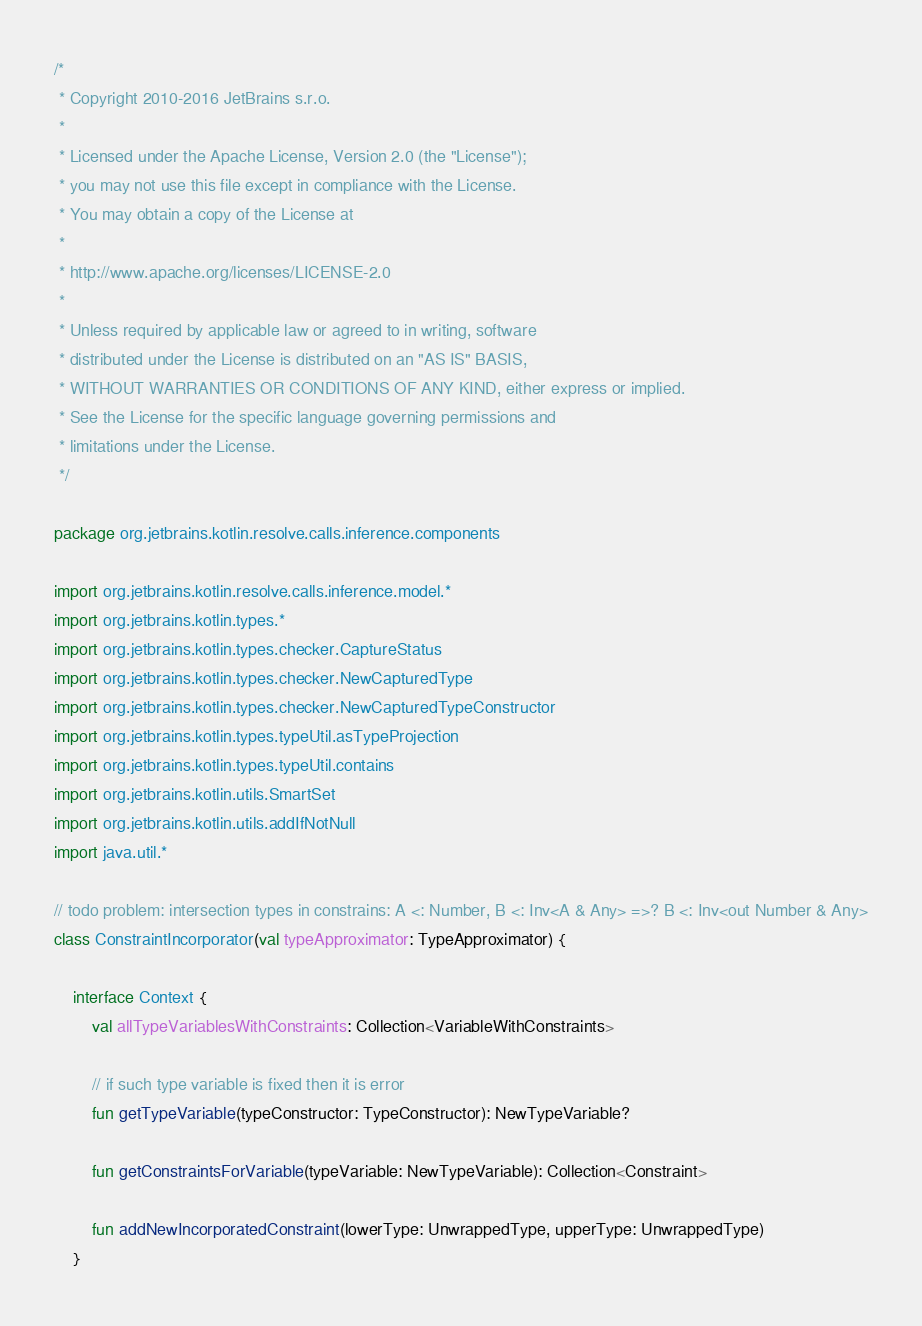Convert code to text. <code><loc_0><loc_0><loc_500><loc_500><_Kotlin_>/*
 * Copyright 2010-2016 JetBrains s.r.o.
 *
 * Licensed under the Apache License, Version 2.0 (the "License");
 * you may not use this file except in compliance with the License.
 * You may obtain a copy of the License at
 *
 * http://www.apache.org/licenses/LICENSE-2.0
 *
 * Unless required by applicable law or agreed to in writing, software
 * distributed under the License is distributed on an "AS IS" BASIS,
 * WITHOUT WARRANTIES OR CONDITIONS OF ANY KIND, either express or implied.
 * See the License for the specific language governing permissions and
 * limitations under the License.
 */

package org.jetbrains.kotlin.resolve.calls.inference.components

import org.jetbrains.kotlin.resolve.calls.inference.model.*
import org.jetbrains.kotlin.types.*
import org.jetbrains.kotlin.types.checker.CaptureStatus
import org.jetbrains.kotlin.types.checker.NewCapturedType
import org.jetbrains.kotlin.types.checker.NewCapturedTypeConstructor
import org.jetbrains.kotlin.types.typeUtil.asTypeProjection
import org.jetbrains.kotlin.types.typeUtil.contains
import org.jetbrains.kotlin.utils.SmartSet
import org.jetbrains.kotlin.utils.addIfNotNull
import java.util.*

// todo problem: intersection types in constrains: A <: Number, B <: Inv<A & Any> =>? B <: Inv<out Number & Any>
class ConstraintIncorporator(val typeApproximator: TypeApproximator) {

    interface Context {
        val allTypeVariablesWithConstraints: Collection<VariableWithConstraints>

        // if such type variable is fixed then it is error
        fun getTypeVariable(typeConstructor: TypeConstructor): NewTypeVariable?

        fun getConstraintsForVariable(typeVariable: NewTypeVariable): Collection<Constraint>

        fun addNewIncorporatedConstraint(lowerType: UnwrappedType, upperType: UnwrappedType)
    }
</code> 